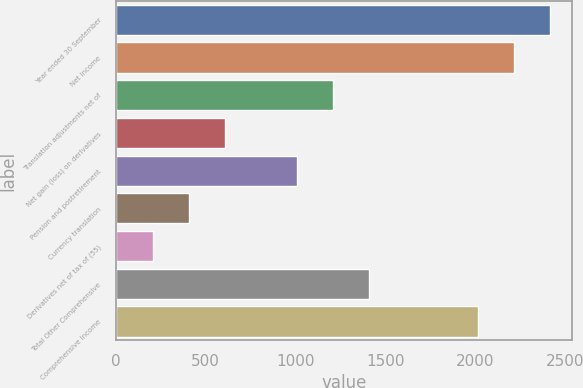Convert chart. <chart><loc_0><loc_0><loc_500><loc_500><bar_chart><fcel>Year ended 30 September<fcel>Net Income<fcel>Translation adjustments net of<fcel>Net gain (loss) on derivatives<fcel>Pension and postretirement<fcel>Currency translation<fcel>Derivatives net of tax of (55)<fcel>Total Other Comprehensive<fcel>Comprehensive Income<nl><fcel>2413.42<fcel>2212.71<fcel>1209.16<fcel>607.03<fcel>1008.45<fcel>406.32<fcel>205.61<fcel>1409.87<fcel>2012<nl></chart> 